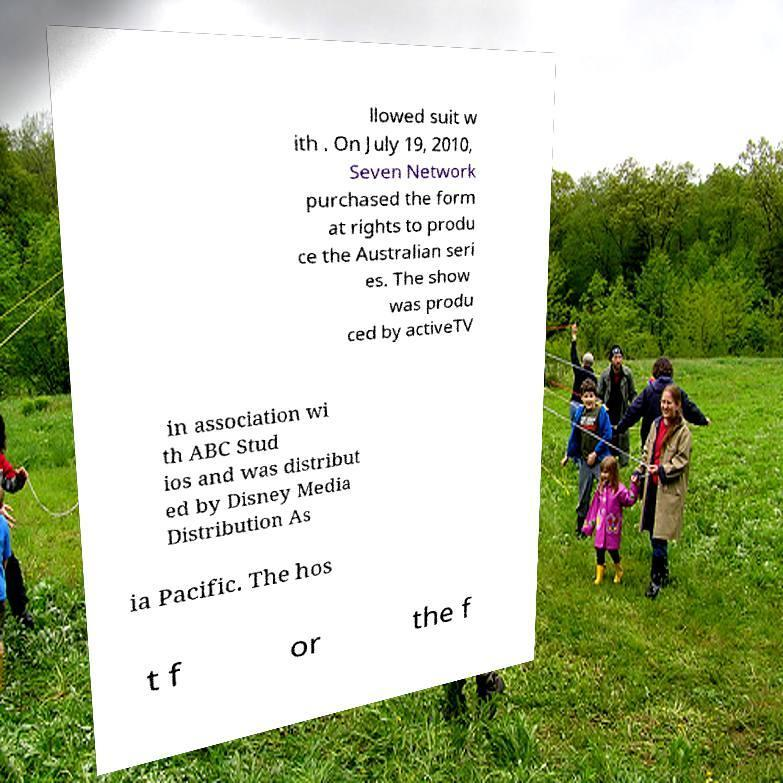Please identify and transcribe the text found in this image. llowed suit w ith . On July 19, 2010, Seven Network purchased the form at rights to produ ce the Australian seri es. The show was produ ced by activeTV in association wi th ABC Stud ios and was distribut ed by Disney Media Distribution As ia Pacific. The hos t f or the f 